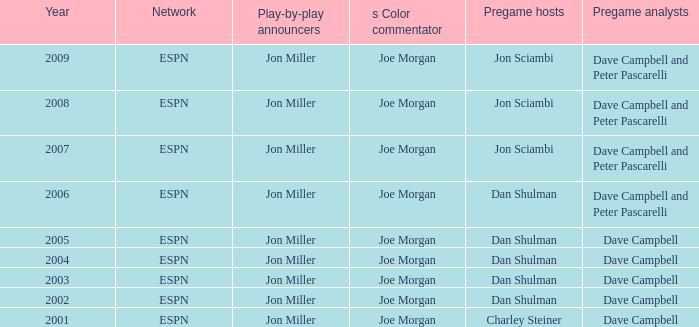How many networks are listed when the year is 2008? 1.0. 